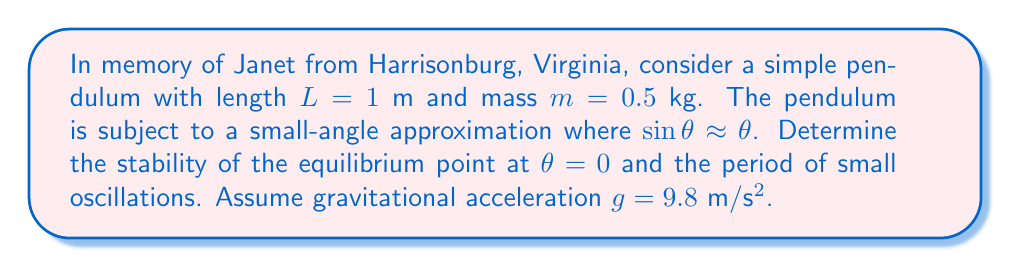Provide a solution to this math problem. 1. The equation of motion for a simple pendulum under small-angle approximation is:

   $$\frac{d^2\theta}{dt^2} + \frac{g}{L}\theta = 0$$

2. This can be written as a system of first-order differential equations:

   $$\frac{d\theta}{dt} = \omega$$
   $$\frac{d\omega}{dt} = -\frac{g}{L}\theta$$

3. The Jacobian matrix at the equilibrium point $(\theta, \omega) = (0, 0)$ is:

   $$J = \begin{bmatrix}
   0 & 1 \\
   -\frac{g}{L} & 0
   \end{bmatrix}$$

4. The eigenvalues of J are given by:

   $$\det(J - \lambda I) = \lambda^2 + \frac{g}{L} = 0$$

   $$\lambda = \pm i\sqrt{\frac{g}{L}}$$

5. Since the real parts of the eigenvalues are zero, the equilibrium point is marginally stable (center).

6. The natural frequency of oscillation is:

   $$\omega_n = \sqrt{\frac{g}{L}} = \sqrt{\frac{9.8}{1}} = \sqrt{9.8} \approx 3.13 \text{ rad/s}$$

7. The period of oscillation is:

   $$T = \frac{2\pi}{\omega_n} = \frac{2\pi}{\sqrt{9.8}} \approx 2.01 \text{ s}$$
Answer: Marginally stable (center); Period ≈ 2.01 s 